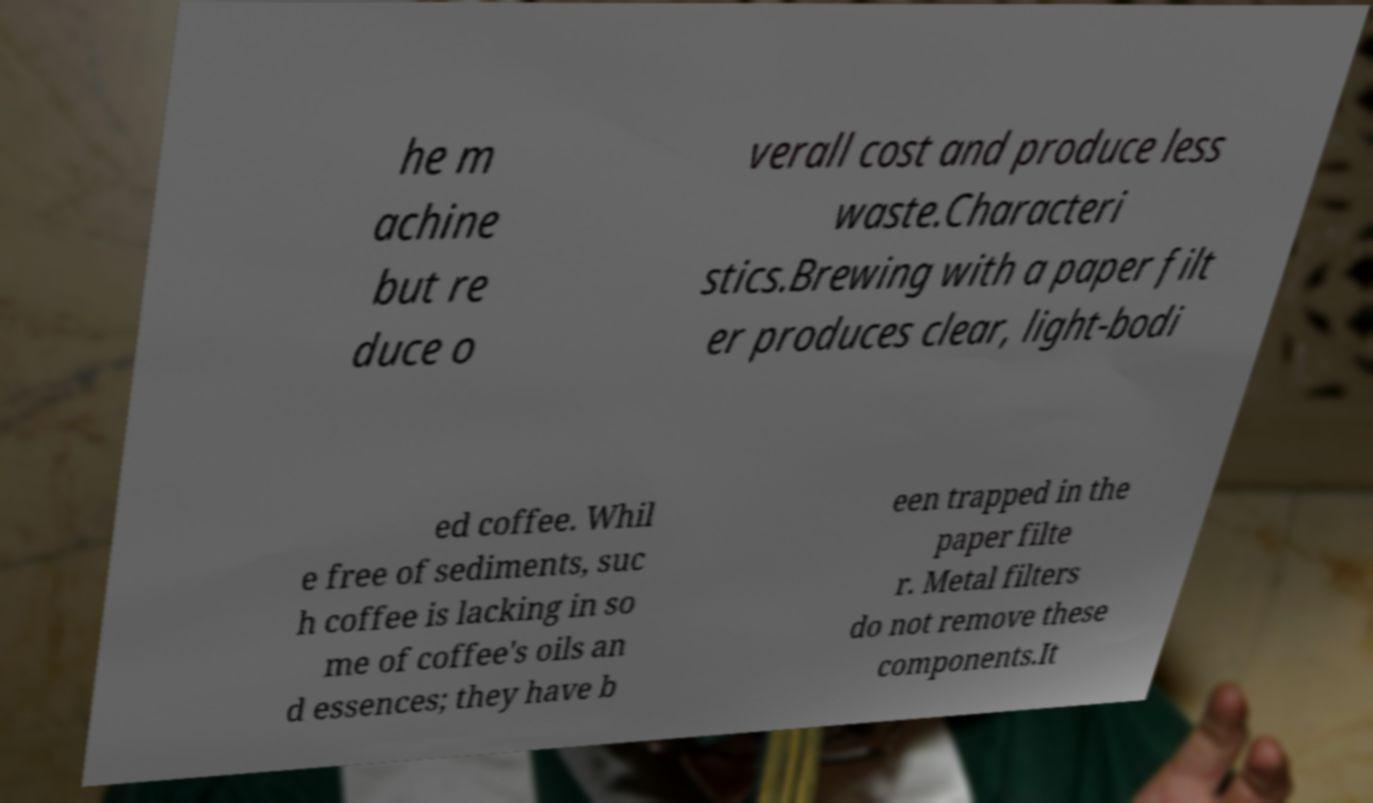Could you assist in decoding the text presented in this image and type it out clearly? he m achine but re duce o verall cost and produce less waste.Characteri stics.Brewing with a paper filt er produces clear, light-bodi ed coffee. Whil e free of sediments, suc h coffee is lacking in so me of coffee's oils an d essences; they have b een trapped in the paper filte r. Metal filters do not remove these components.It 